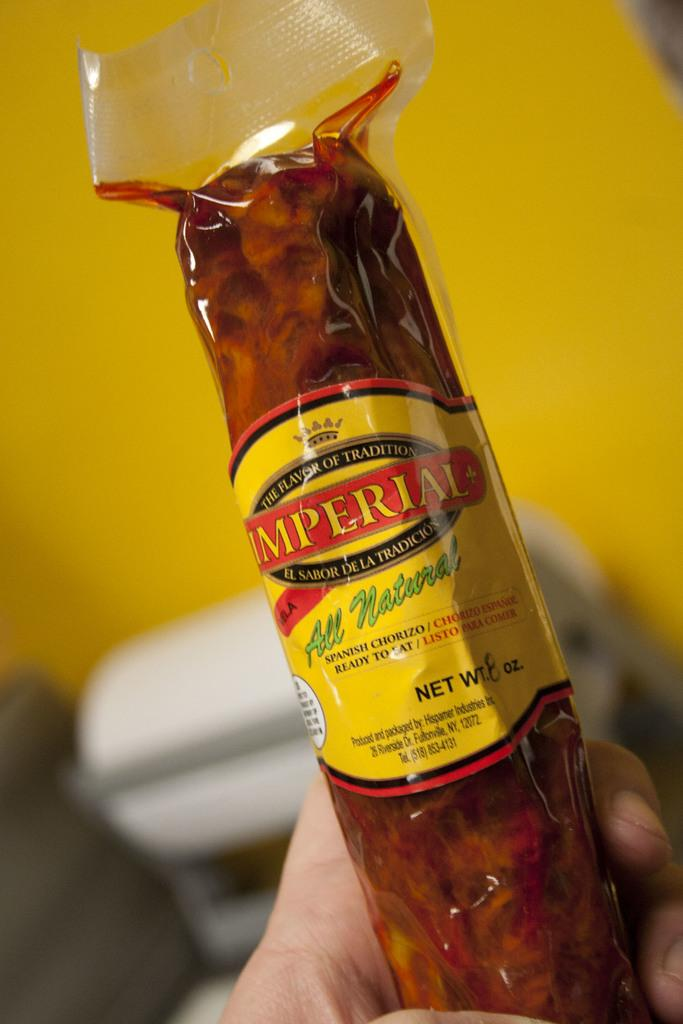<image>
Offer a succinct explanation of the picture presented. A clear package of all natural Imperial sausage with a yellow and red label 